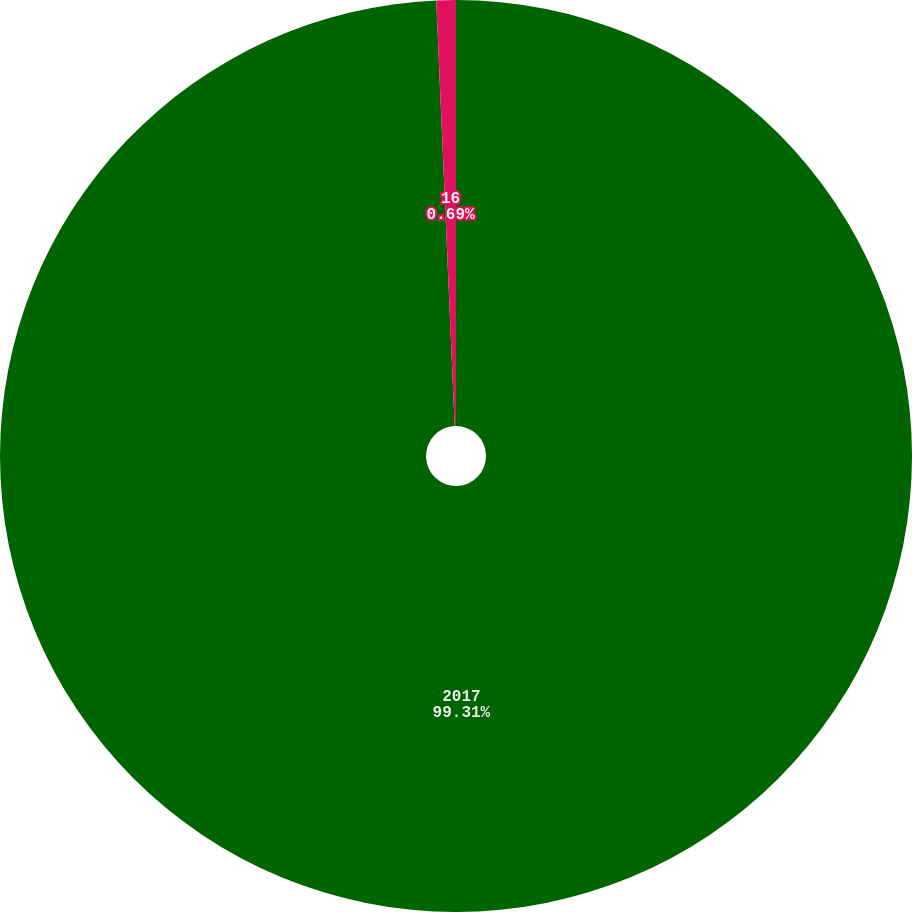<chart> <loc_0><loc_0><loc_500><loc_500><pie_chart><fcel>2017<fcel>16<nl><fcel>99.31%<fcel>0.69%<nl></chart> 